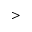<formula> <loc_0><loc_0><loc_500><loc_500>></formula> 